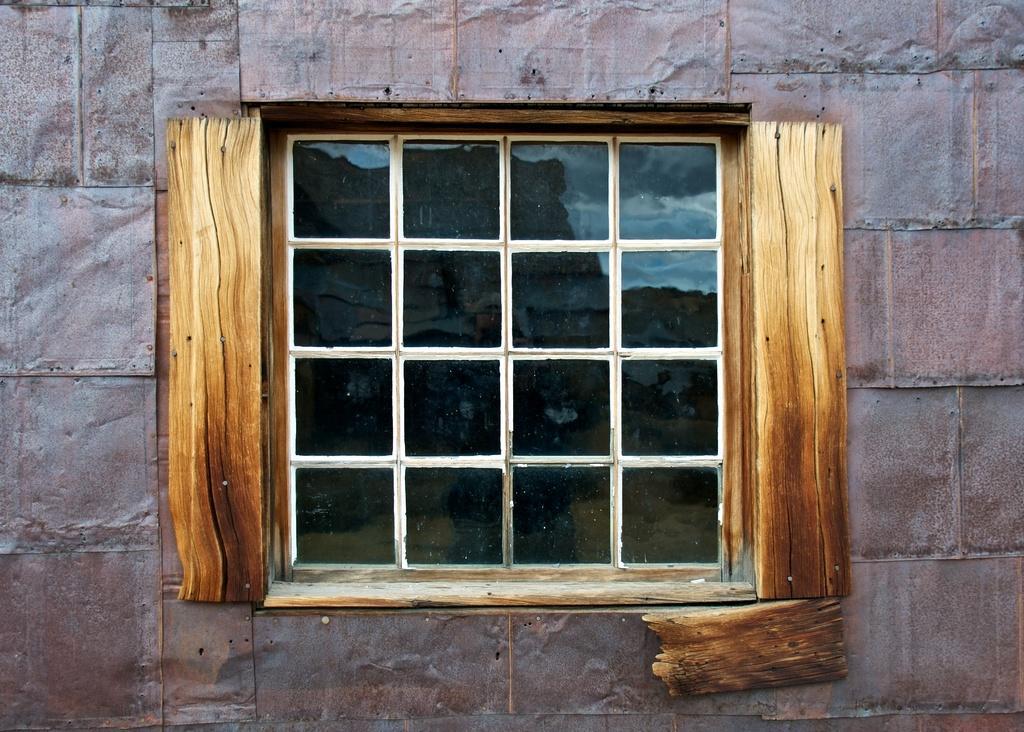Could you give a brief overview of what you see in this image? In the image we can see there is a window on the wall and there are square shape partitions on the window. There are iron sheets pinned on the wall and there are wooden sheets pinned on the boundary of the window. 